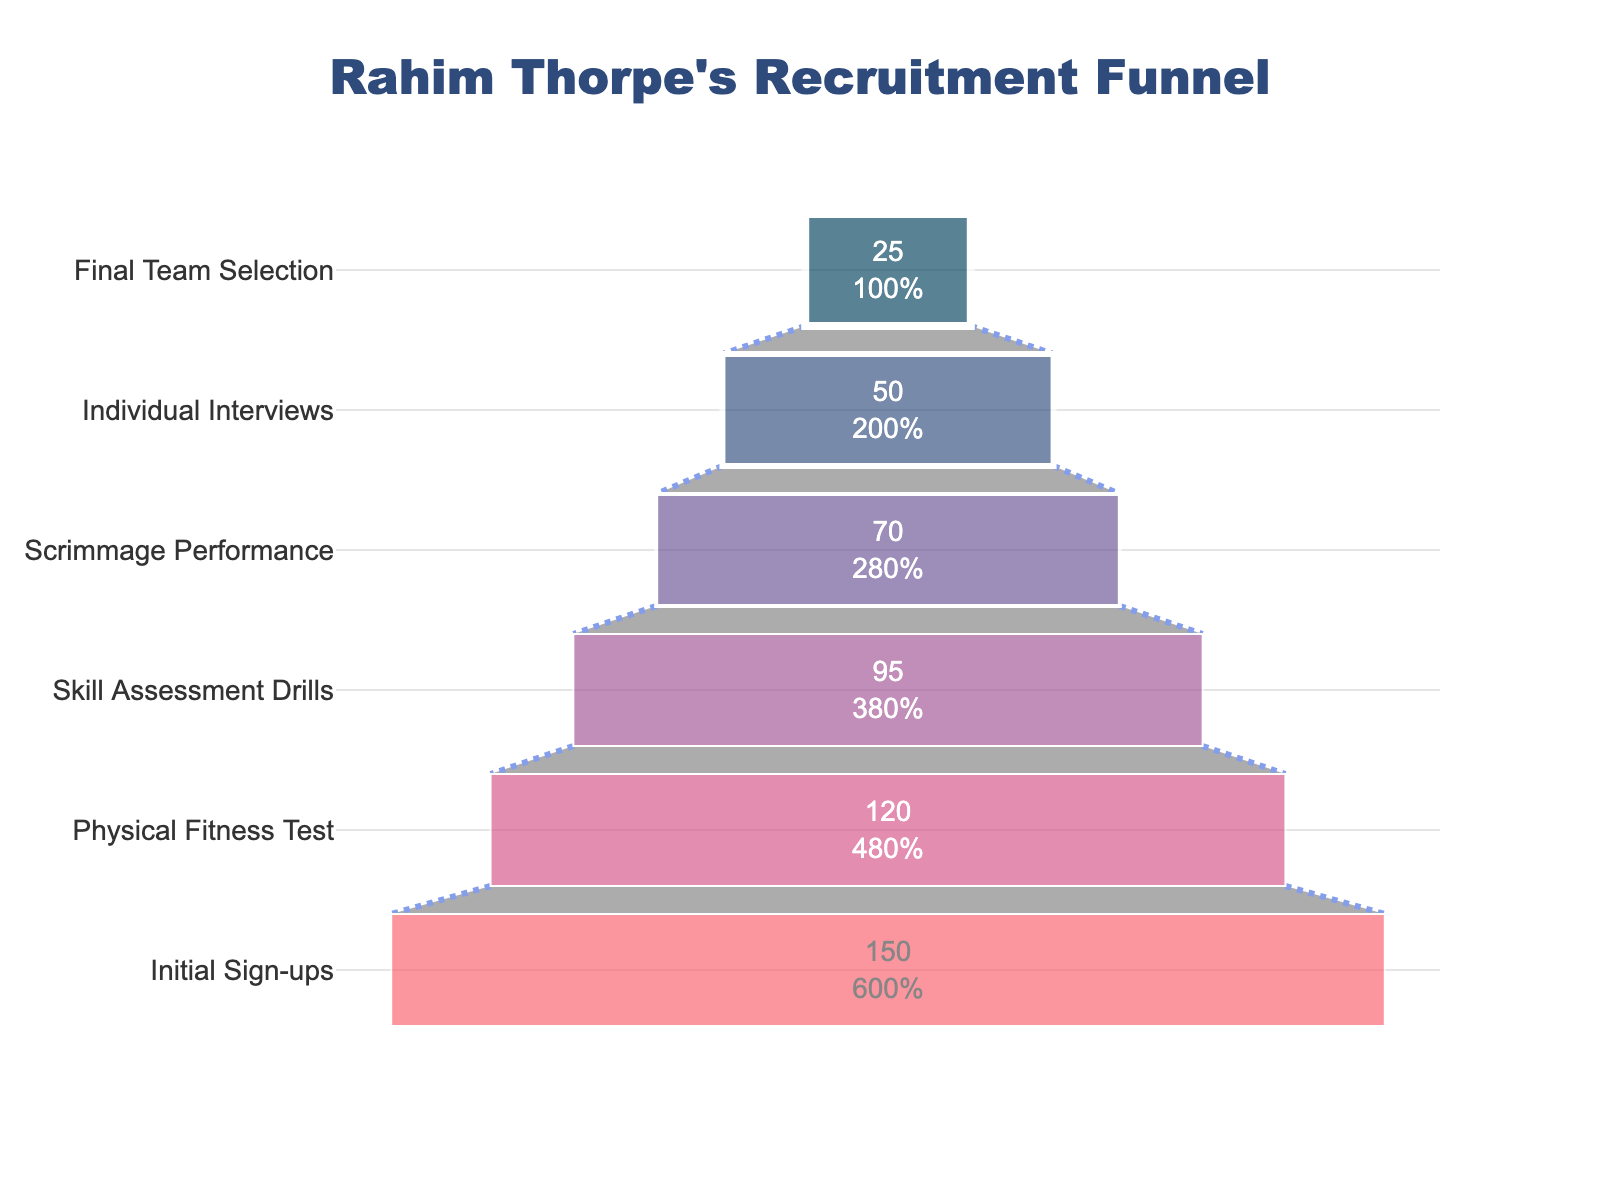what is the title of the chart? The title of the chart is prominently displayed at the top of the figure. It reads "Rahim Thorpe's Recruitment Funnel."
Answer: Rahim Thorpe's Recruitment Funnel Which stage has the highest number of participants? By looking at the funnel chart, the width of the bars indicates the number of participants at each stage. The "Initial Sign-ups" stage has the widest bar.
Answer: Initial Sign-ups What is the percentage of participants left after the Physical Fitness Test? The funnel chart shows both the number of participants and the percentage relative to the initial stage. After the Physical Fitness Test, it shows that 120 participants remain out of the initial 150, which is (120/150) * 100%.
Answer: 80% How many stages are there in total? Count the horizontal bars or labels on the y-axis of the funnel chart. There are six stages listed.
Answer: 6 What is the difference in participant numbers between the Scrimmage Performance and the Final Team Selection? The number of participants at the Scrimmage Performance stage is 70 and at the Final Team Selection stage is 25. Subtract 25 from 70 to get the difference.
Answer: 45 What percentage of the initial participants make it to the Final Team Selection? The funnel chart provides both the value and the percentage. To calculate, take 25 (Final Team Selection) divided by 150 (Initial Sign-ups) and multiply by 100%.
Answer: 16.67% Which transition stage saw the largest drop in participants? By looking at the difference in participant numbers between consecutive stages, the transition from the Skill Assessment Drills (95 participants) to Scrimmage Performance (70 participants) shows the largest drop of 25 participants.
Answer: Skill Assessment Drills to Scrimmage Performance What color represents the Individual Interviews stage? The color bar corresponding to the "Individual Interviews" stage is one of the specific colors used. This stage is marked in a deep pinkish-red color.
Answer: Deep pinkish-red Compare the number of participants in the Physical Fitness Test and the Skill Assessment Drills. Which stage has more participants and by how much? The number of participants in the Physical Fitness Test is 120, and in the Skill Assessment Drills is 95. Subtract 95 from 120 to find that the Physical Fitness Test has 25 more participants.
Answer: Physical Fitness Test by 25 